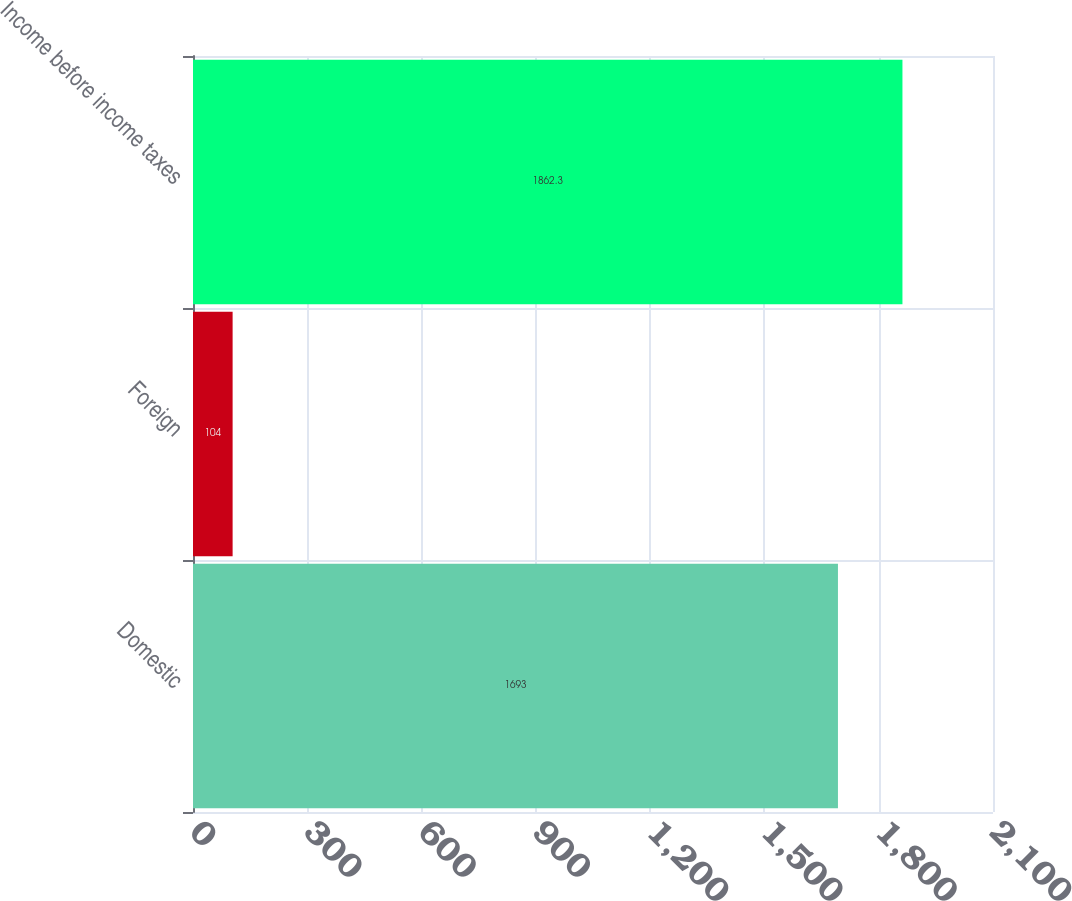<chart> <loc_0><loc_0><loc_500><loc_500><bar_chart><fcel>Domestic<fcel>Foreign<fcel>Income before income taxes<nl><fcel>1693<fcel>104<fcel>1862.3<nl></chart> 